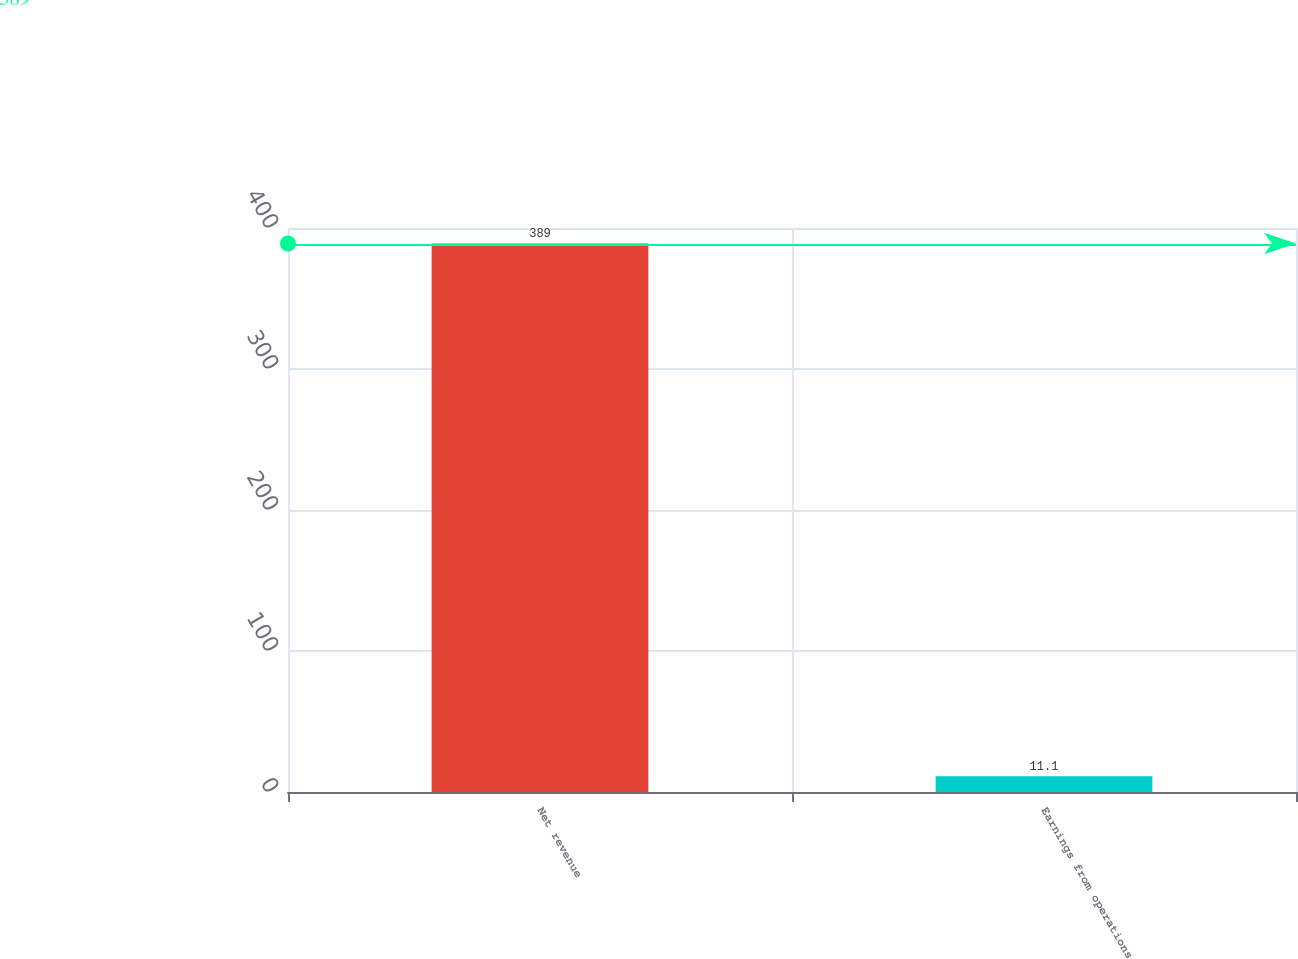<chart> <loc_0><loc_0><loc_500><loc_500><bar_chart><fcel>Net revenue<fcel>Earnings from operations<nl><fcel>389<fcel>11.1<nl></chart> 